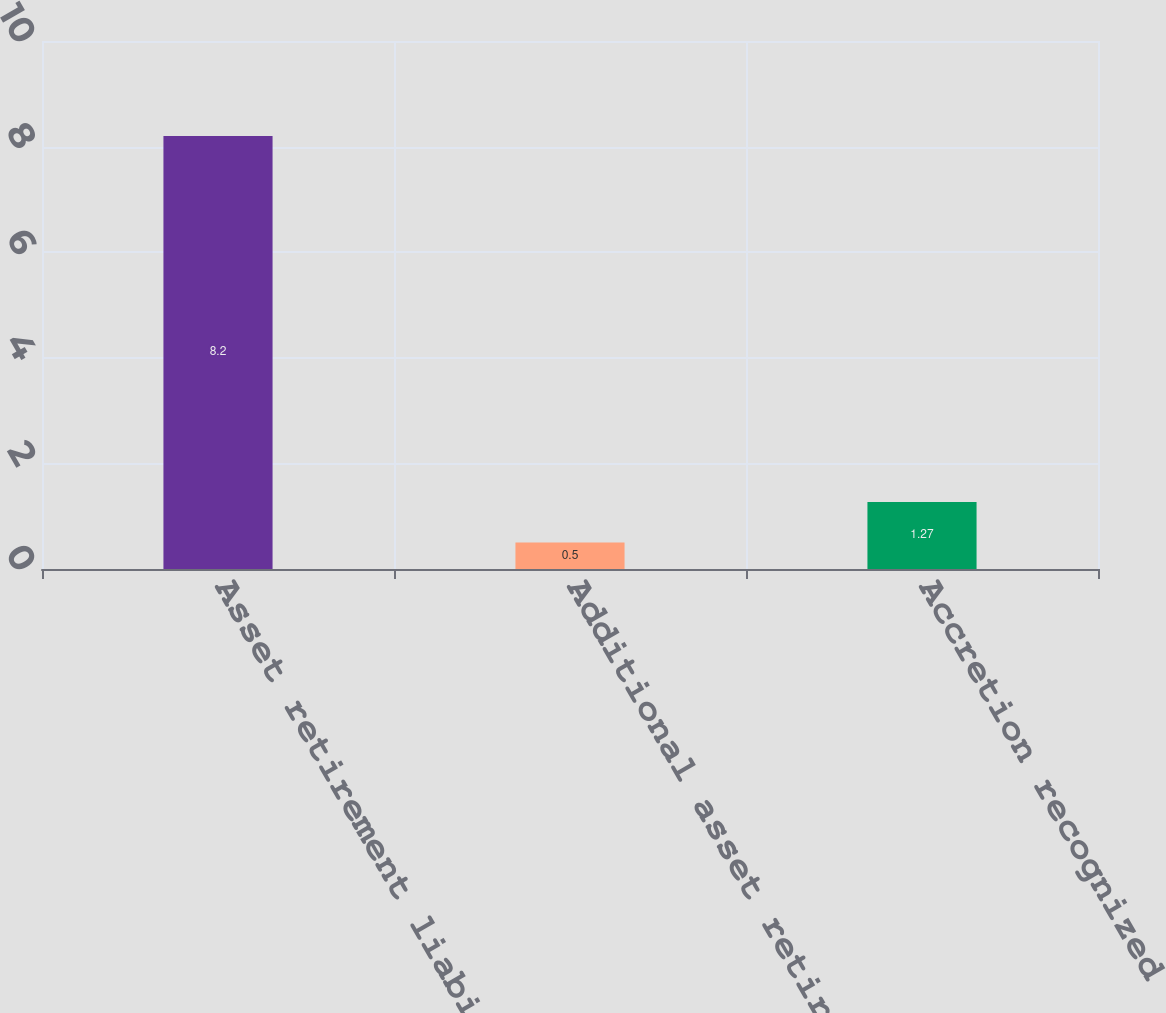Convert chart. <chart><loc_0><loc_0><loc_500><loc_500><bar_chart><fcel>Asset retirement liability as<fcel>Additional asset retirement<fcel>Accretion recognized<nl><fcel>8.2<fcel>0.5<fcel>1.27<nl></chart> 